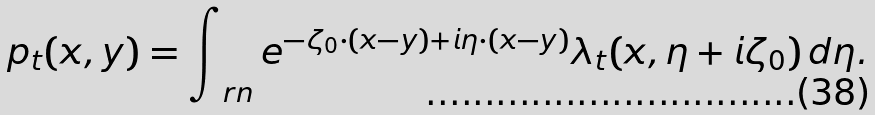Convert formula to latex. <formula><loc_0><loc_0><loc_500><loc_500>p _ { t } ( x , y ) = \int _ { \ r n } e ^ { - \zeta _ { 0 } \cdot ( x - y ) + i \eta \cdot ( x - y ) } \lambda _ { t } ( x , \eta + i \zeta _ { 0 } ) \, d \eta .</formula> 